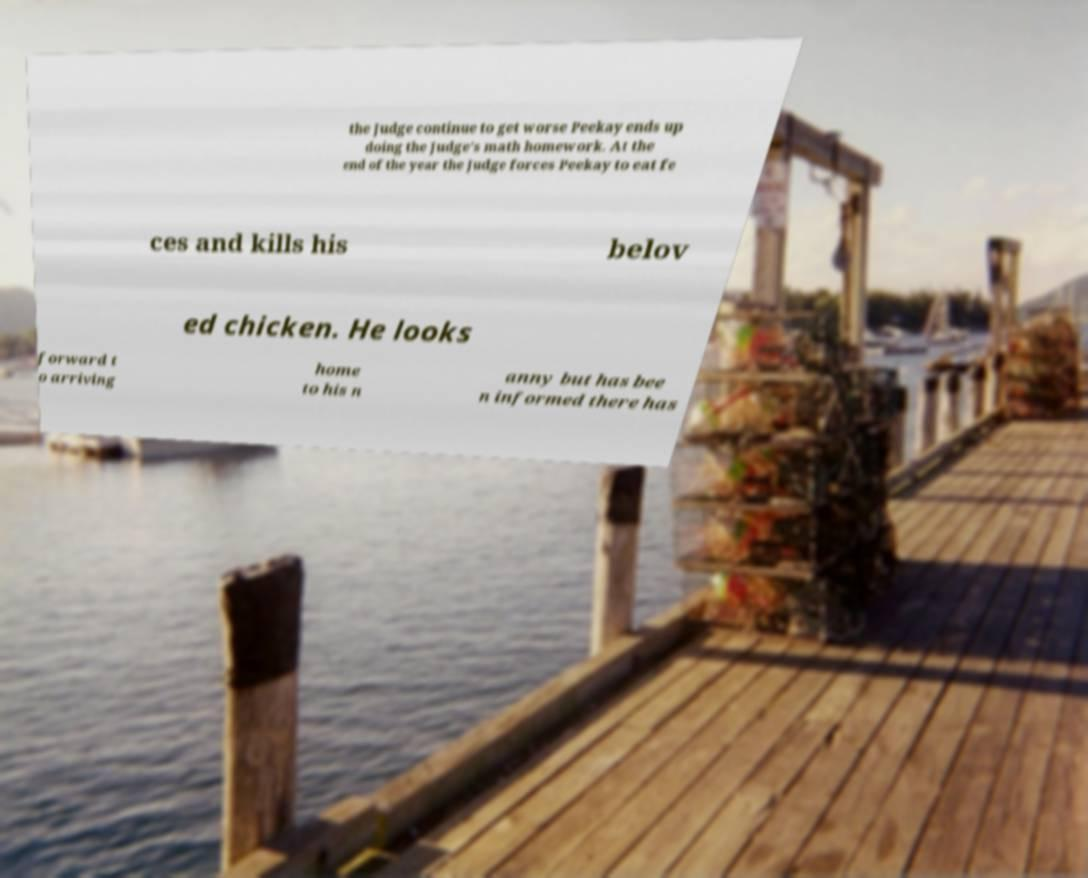I need the written content from this picture converted into text. Can you do that? the Judge continue to get worse Peekay ends up doing the Judge's math homework. At the end of the year the Judge forces Peekay to eat fe ces and kills his belov ed chicken. He looks forward t o arriving home to his n anny but has bee n informed there has 